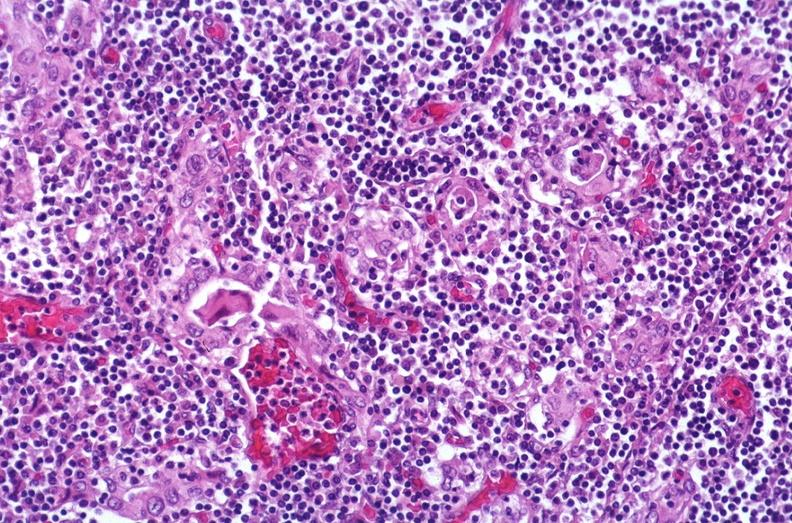what is present?
Answer the question using a single word or phrase. Endocrine 